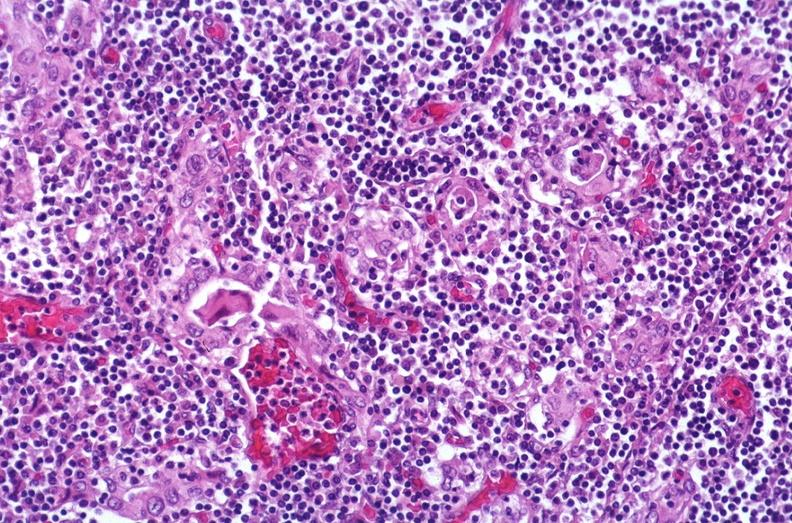what is present?
Answer the question using a single word or phrase. Endocrine 